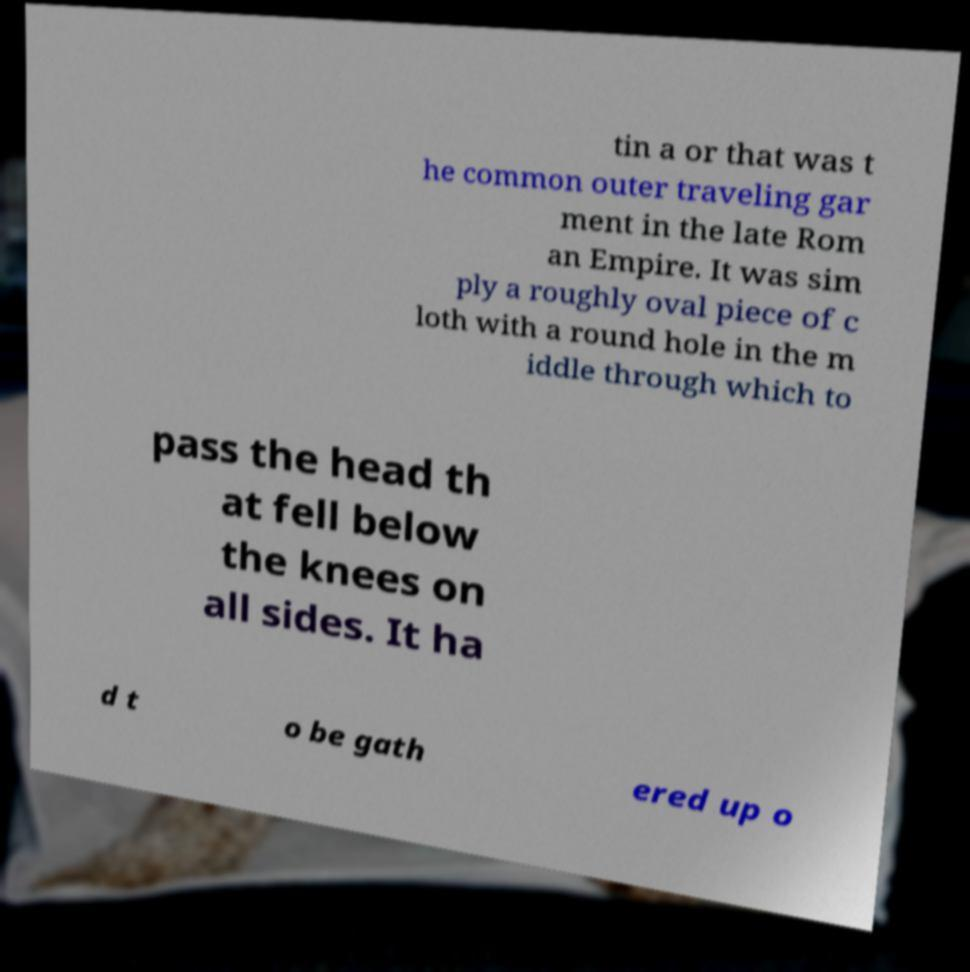Could you assist in decoding the text presented in this image and type it out clearly? tin a or that was t he common outer traveling gar ment in the late Rom an Empire. It was sim ply a roughly oval piece of c loth with a round hole in the m iddle through which to pass the head th at fell below the knees on all sides. It ha d t o be gath ered up o 